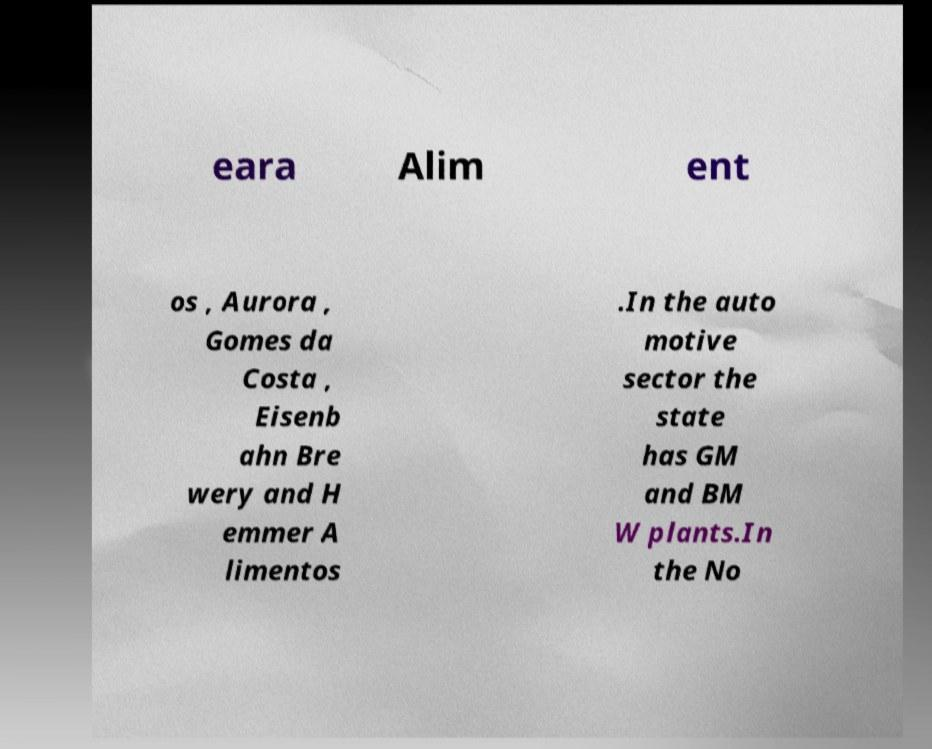There's text embedded in this image that I need extracted. Can you transcribe it verbatim? eara Alim ent os , Aurora , Gomes da Costa , Eisenb ahn Bre wery and H emmer A limentos .In the auto motive sector the state has GM and BM W plants.In the No 